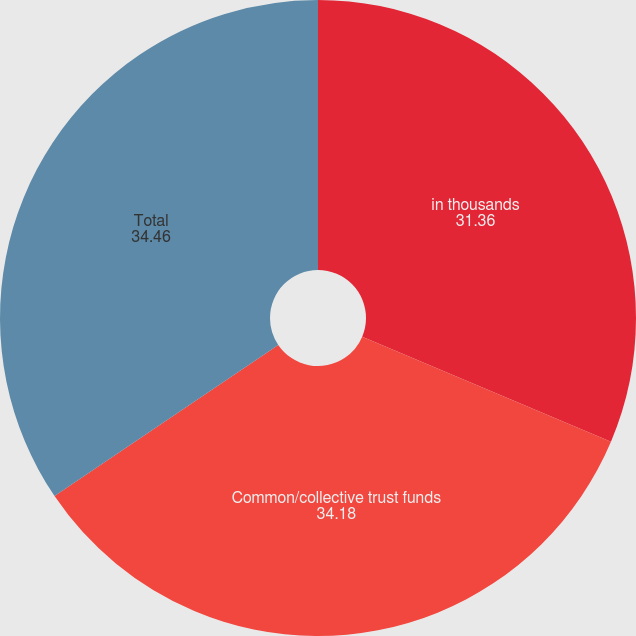<chart> <loc_0><loc_0><loc_500><loc_500><pie_chart><fcel>in thousands<fcel>Common/collective trust funds<fcel>Total<nl><fcel>31.36%<fcel>34.18%<fcel>34.46%<nl></chart> 